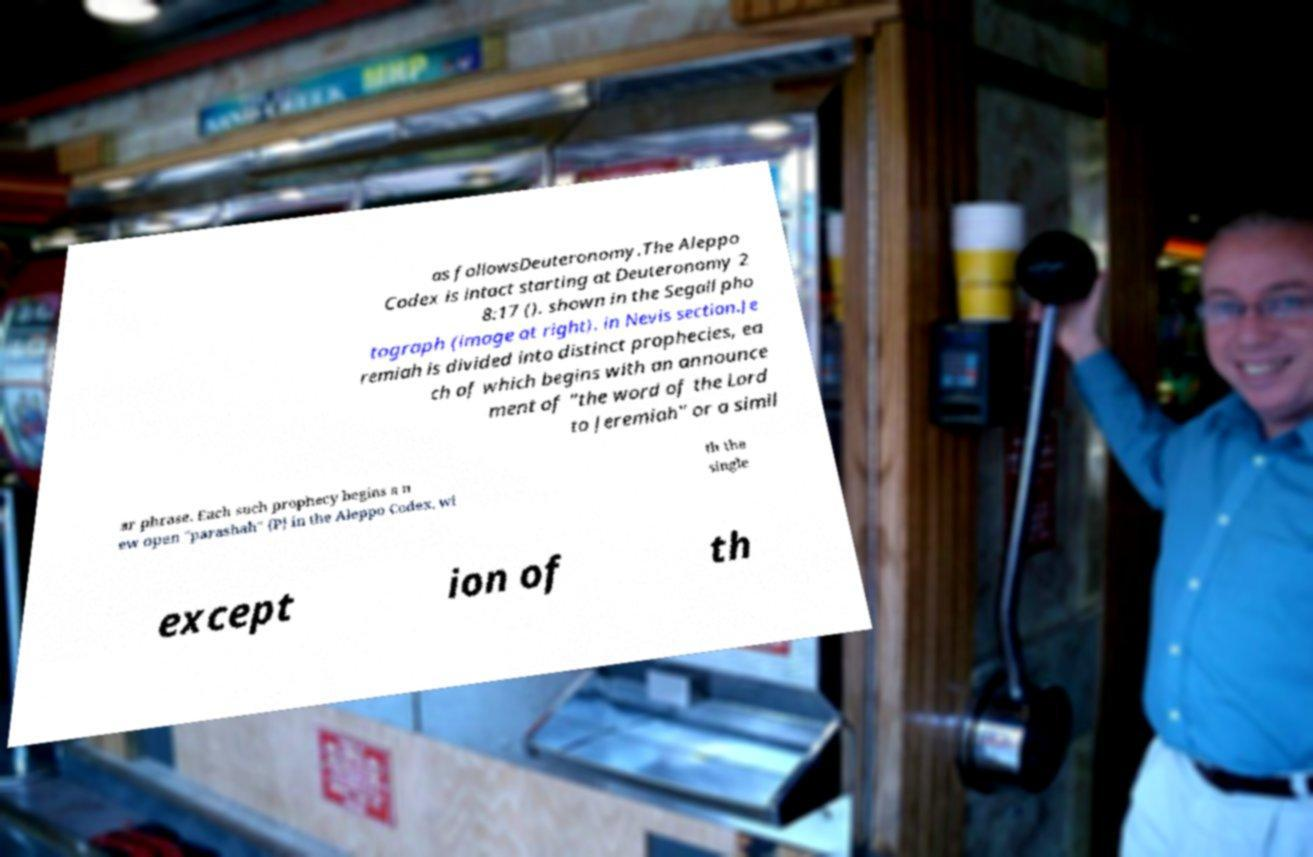For documentation purposes, I need the text within this image transcribed. Could you provide that? as followsDeuteronomy.The Aleppo Codex is intact starting at Deuteronomy 2 8:17 (). shown in the Segall pho tograph (image at right). in Nevis section.Je remiah is divided into distinct prophecies, ea ch of which begins with an announce ment of "the word of the Lord to Jeremiah" or a simil ar phrase. Each such prophecy begins a n ew open "parashah" {P} in the Aleppo Codex, wi th the single except ion of th 